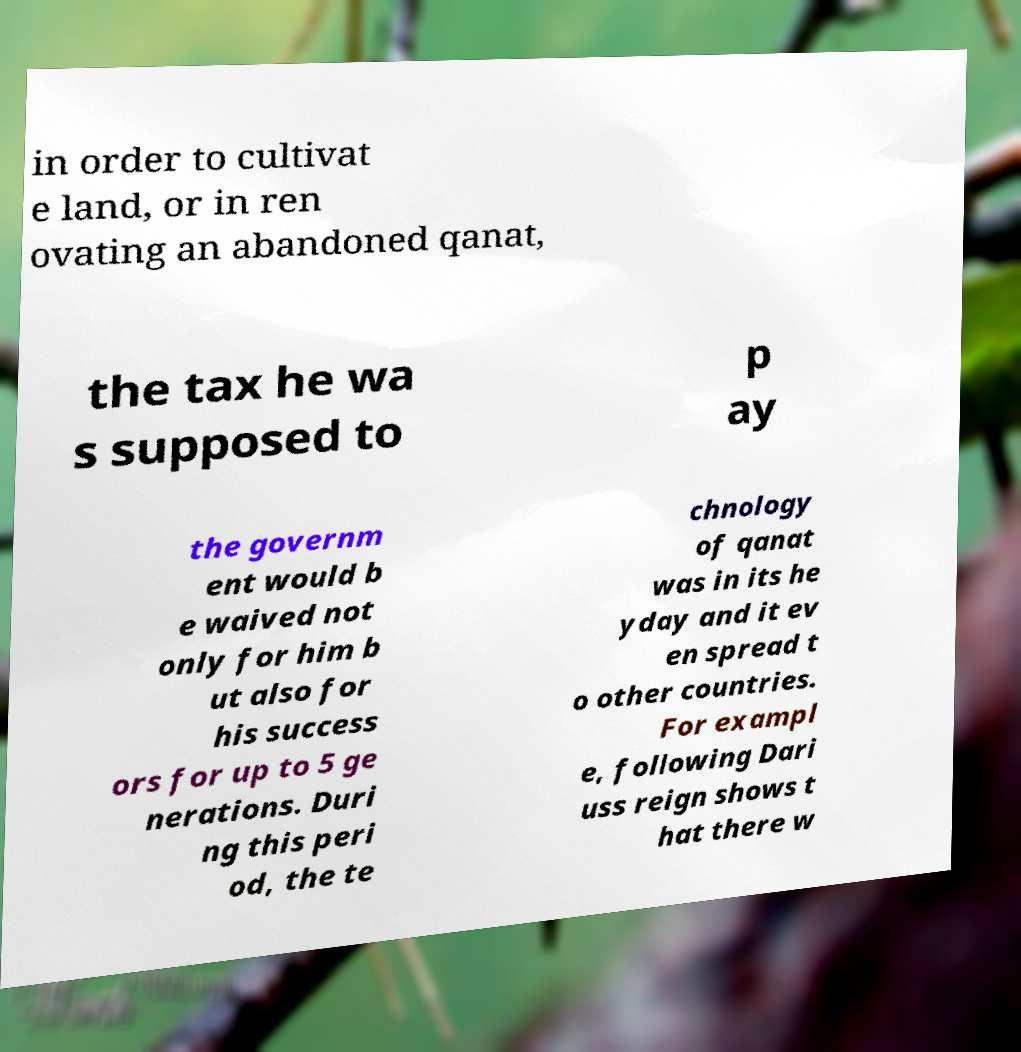I need the written content from this picture converted into text. Can you do that? in order to cultivat e land, or in ren ovating an abandoned qanat, the tax he wa s supposed to p ay the governm ent would b e waived not only for him b ut also for his success ors for up to 5 ge nerations. Duri ng this peri od, the te chnology of qanat was in its he yday and it ev en spread t o other countries. For exampl e, following Dari uss reign shows t hat there w 